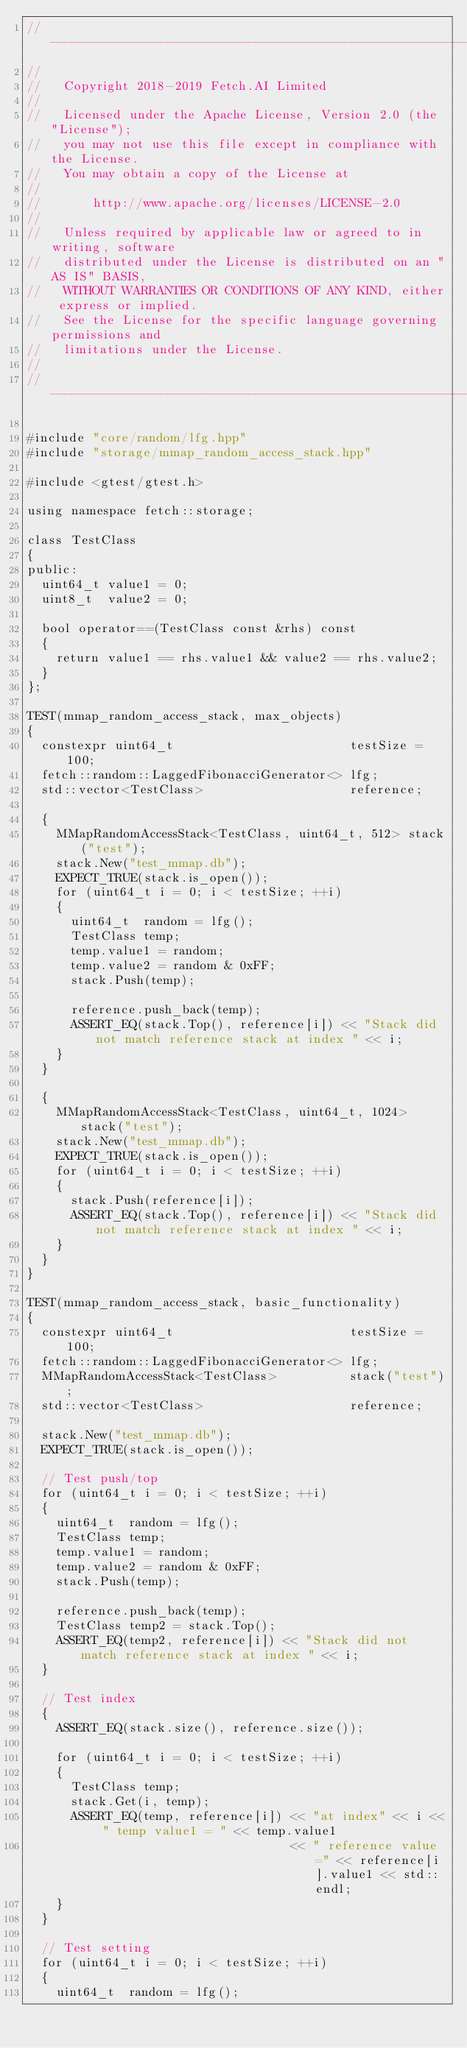<code> <loc_0><loc_0><loc_500><loc_500><_C++_>//------------------------------------------------------------------------------
//
//   Copyright 2018-2019 Fetch.AI Limited
//
//   Licensed under the Apache License, Version 2.0 (the "License");
//   you may not use this file except in compliance with the License.
//   You may obtain a copy of the License at
//
//       http://www.apache.org/licenses/LICENSE-2.0
//
//   Unless required by applicable law or agreed to in writing, software
//   distributed under the License is distributed on an "AS IS" BASIS,
//   WITHOUT WARRANTIES OR CONDITIONS OF ANY KIND, either express or implied.
//   See the License for the specific language governing permissions and
//   limitations under the License.
//
//------------------------------------------------------------------------------

#include "core/random/lfg.hpp"
#include "storage/mmap_random_access_stack.hpp"

#include <gtest/gtest.h>

using namespace fetch::storage;

class TestClass
{
public:
  uint64_t value1 = 0;
  uint8_t  value2 = 0;

  bool operator==(TestClass const &rhs) const
  {
    return value1 == rhs.value1 && value2 == rhs.value2;
  }
};

TEST(mmap_random_access_stack, max_objects)
{
  constexpr uint64_t                        testSize = 100;
  fetch::random::LaggedFibonacciGenerator<> lfg;
  std::vector<TestClass>                    reference;

  {
    MMapRandomAccessStack<TestClass, uint64_t, 512> stack("test");
    stack.New("test_mmap.db");
    EXPECT_TRUE(stack.is_open());
    for (uint64_t i = 0; i < testSize; ++i)
    {
      uint64_t  random = lfg();
      TestClass temp;
      temp.value1 = random;
      temp.value2 = random & 0xFF;
      stack.Push(temp);

      reference.push_back(temp);
      ASSERT_EQ(stack.Top(), reference[i]) << "Stack did not match reference stack at index " << i;
    }
  }

  {
    MMapRandomAccessStack<TestClass, uint64_t, 1024> stack("test");
    stack.New("test_mmap.db");
    EXPECT_TRUE(stack.is_open());
    for (uint64_t i = 0; i < testSize; ++i)
    {
      stack.Push(reference[i]);
      ASSERT_EQ(stack.Top(), reference[i]) << "Stack did not match reference stack at index " << i;
    }
  }
}

TEST(mmap_random_access_stack, basic_functionality)
{
  constexpr uint64_t                        testSize = 100;
  fetch::random::LaggedFibonacciGenerator<> lfg;
  MMapRandomAccessStack<TestClass>          stack("test");
  std::vector<TestClass>                    reference;

  stack.New("test_mmap.db");
  EXPECT_TRUE(stack.is_open());

  // Test push/top
  for (uint64_t i = 0; i < testSize; ++i)
  {
    uint64_t  random = lfg();
    TestClass temp;
    temp.value1 = random;
    temp.value2 = random & 0xFF;
    stack.Push(temp);

    reference.push_back(temp);
    TestClass temp2 = stack.Top();
    ASSERT_EQ(temp2, reference[i]) << "Stack did not match reference stack at index " << i;
  }

  // Test index
  {
    ASSERT_EQ(stack.size(), reference.size());

    for (uint64_t i = 0; i < testSize; ++i)
    {
      TestClass temp;
      stack.Get(i, temp);
      ASSERT_EQ(temp, reference[i]) << "at index" << i << " temp value1 = " << temp.value1
                                    << " reference value =" << reference[i].value1 << std::endl;
    }
  }

  // Test setting
  for (uint64_t i = 0; i < testSize; ++i)
  {
    uint64_t  random = lfg();</code> 